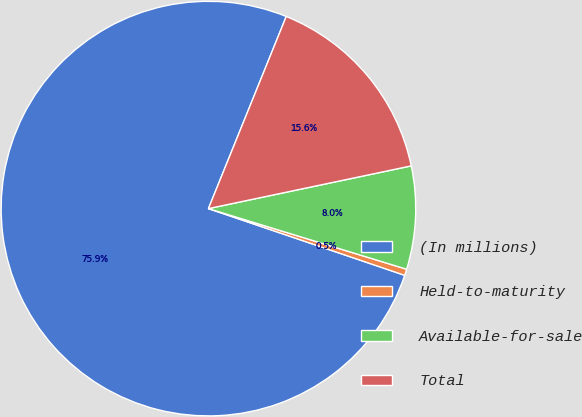<chart> <loc_0><loc_0><loc_500><loc_500><pie_chart><fcel>(In millions)<fcel>Held-to-maturity<fcel>Available-for-sale<fcel>Total<nl><fcel>75.91%<fcel>0.49%<fcel>8.03%<fcel>15.57%<nl></chart> 